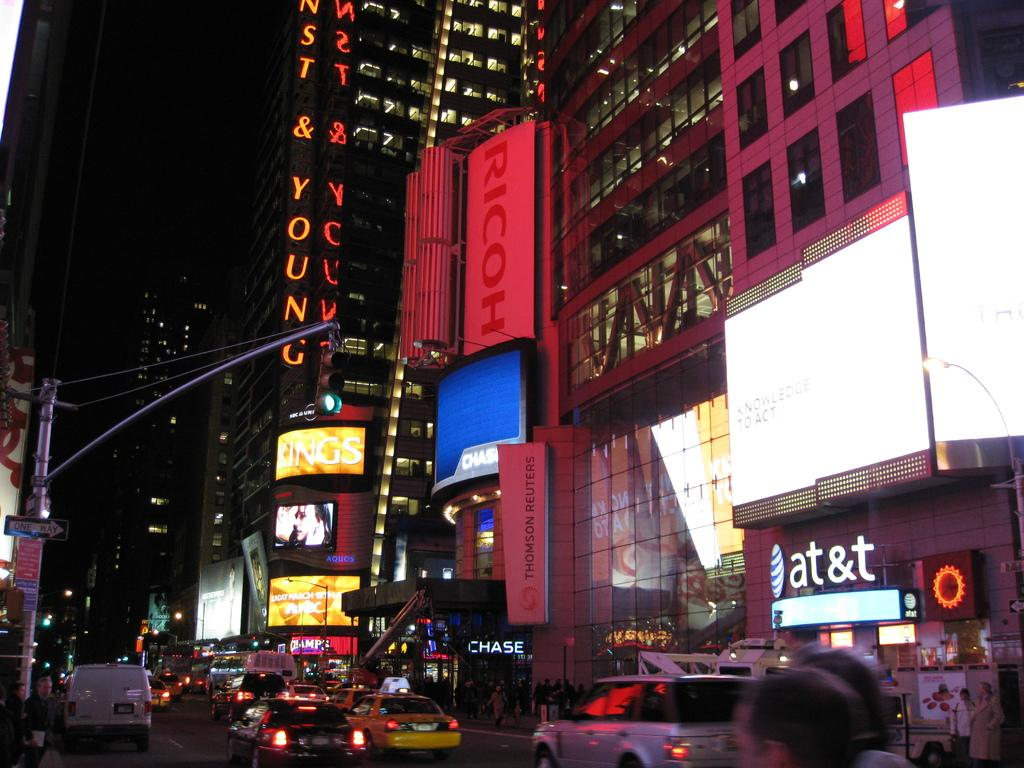<image>
Give a short and clear explanation of the subsequent image. AT&T, Chase Bank and Champs are some of the stores alone a busy New York City street. 